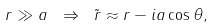Convert formula to latex. <formula><loc_0><loc_0><loc_500><loc_500>r \gg a \ \Rightarrow \ \tilde { r } \approx r - i a \cos \theta ,</formula> 